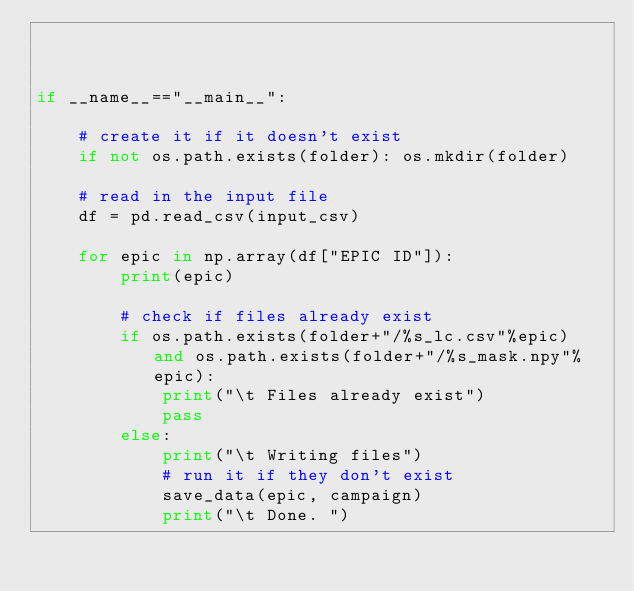Convert code to text. <code><loc_0><loc_0><loc_500><loc_500><_Python_>    
    

if __name__=="__main__":
    
    # create it if it doesn't exist
    if not os.path.exists(folder): os.mkdir(folder)
    
    # read in the input file
    df = pd.read_csv(input_csv)
    
    for epic in np.array(df["EPIC ID"]):
        print(epic)
        
        # check if files already exist
        if os.path.exists(folder+"/%s_lc.csv"%epic) and os.path.exists(folder+"/%s_mask.npy"%epic):
            print("\t Files already exist")
            pass
        else:
            print("\t Writing files")
            # run it if they don't exist
            save_data(epic, campaign)
            print("\t Done. ")</code> 